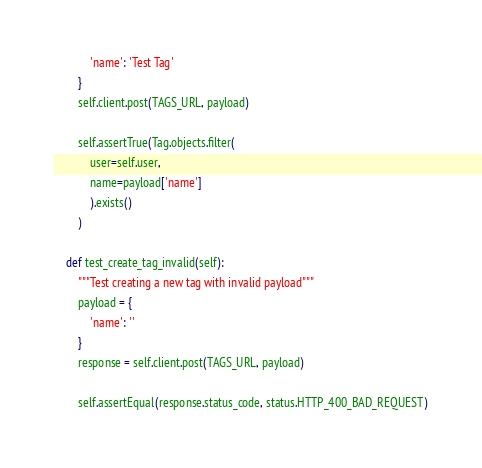<code> <loc_0><loc_0><loc_500><loc_500><_Python_>            'name': 'Test Tag'
        }
        self.client.post(TAGS_URL, payload)

        self.assertTrue(Tag.objects.filter(
            user=self.user,
            name=payload['name']
            ).exists()
        )

    def test_create_tag_invalid(self):
        """Test creating a new tag with invalid payload"""
        payload = {
            'name': ''
        }
        response = self.client.post(TAGS_URL, payload)

        self.assertEqual(response.status_code, status.HTTP_400_BAD_REQUEST)
</code> 